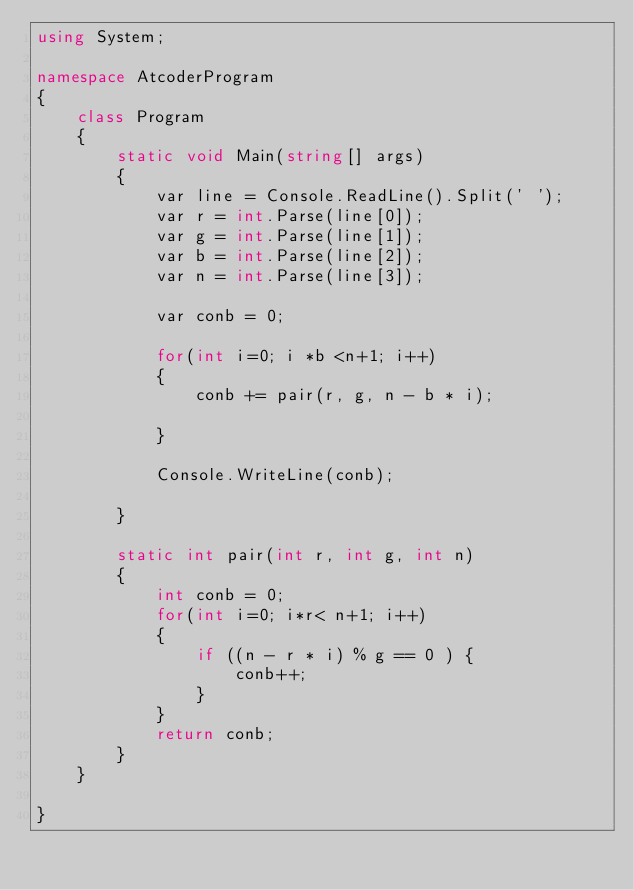<code> <loc_0><loc_0><loc_500><loc_500><_C#_>using System;

namespace AtcoderProgram
{
    class Program
    {
        static void Main(string[] args)
        {
            var line = Console.ReadLine().Split(' ');
            var r = int.Parse(line[0]);
            var g = int.Parse(line[1]);
            var b = int.Parse(line[2]);
            var n = int.Parse(line[3]);

            var conb = 0;

            for(int i=0; i *b <n+1; i++)
            {
                conb += pair(r, g, n - b * i);
              
            }

            Console.WriteLine(conb);

        }

        static int pair(int r, int g, int n)
        {
            int conb = 0;
            for(int i=0; i*r< n+1; i++)
            {
                if ((n - r * i) % g == 0 ) {
                    conb++;
                } 
            }
            return conb;
        }
    }

}
</code> 